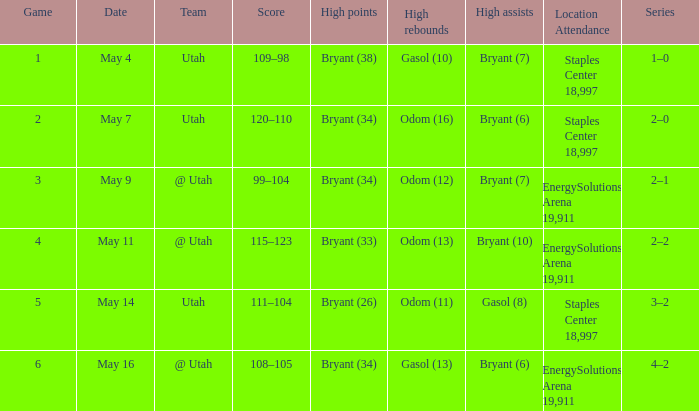What is the High rebounds with a High assists with bryant (7), and a Team of @ utah? Odom (12). 